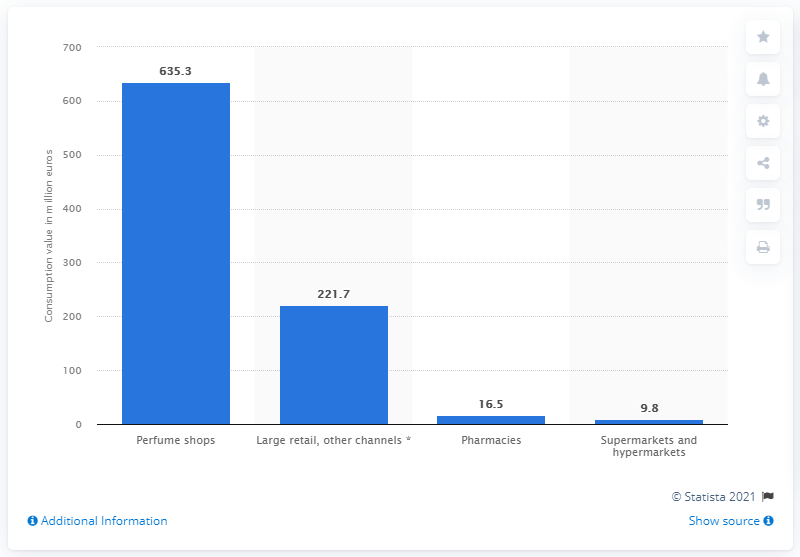Specify some key components in this picture. In 2020, the value of pharmacy consumption in Italy was 9.8 billion euros. In 2020, the average cost of perfumes in Italy was 635.3 euros. 